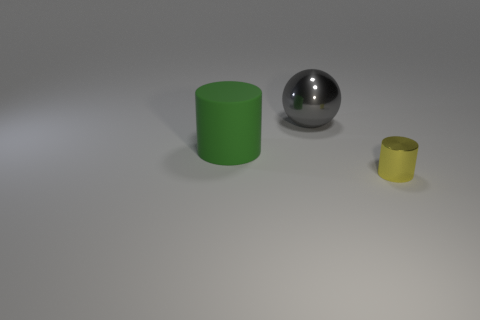Subtract all yellow cylinders. How many cylinders are left? 1 Subtract all balls. How many objects are left? 2 Subtract 2 cylinders. How many cylinders are left? 0 Add 1 green rubber cylinders. How many objects exist? 4 Add 2 small yellow objects. How many small yellow objects exist? 3 Subtract 0 cyan cylinders. How many objects are left? 3 Subtract all cyan cylinders. Subtract all blue spheres. How many cylinders are left? 2 Subtract all brown cylinders. How many green spheres are left? 0 Subtract all yellow shiny objects. Subtract all large spheres. How many objects are left? 1 Add 1 gray metal spheres. How many gray metal spheres are left? 2 